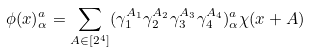Convert formula to latex. <formula><loc_0><loc_0><loc_500><loc_500>\phi ( x ) ^ { a } _ { \alpha } = \sum _ { A \in [ 2 ^ { 4 } ] } ( \gamma _ { 1 } ^ { A _ { 1 } } \gamma _ { 2 } ^ { A _ { 2 } } \gamma _ { 3 } ^ { A _ { 3 } } \gamma _ { 4 } ^ { A _ { 4 } } ) ^ { a } _ { \alpha } \chi ( x + A )</formula> 